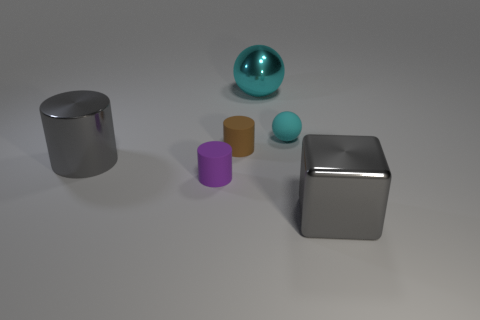Subtract all cyan balls. How many were subtracted if there are1cyan balls left? 1 Add 1 big spheres. How many objects exist? 7 Subtract all blocks. How many objects are left? 5 Add 2 small cyan objects. How many small cyan objects exist? 3 Subtract 0 cyan cubes. How many objects are left? 6 Subtract all small cylinders. Subtract all small green rubber spheres. How many objects are left? 4 Add 3 shiny blocks. How many shiny blocks are left? 4 